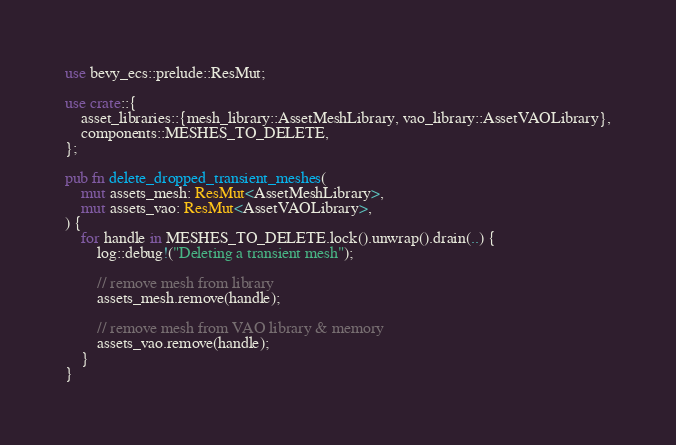<code> <loc_0><loc_0><loc_500><loc_500><_Rust_>use bevy_ecs::prelude::ResMut;

use crate::{
    asset_libraries::{mesh_library::AssetMeshLibrary, vao_library::AssetVAOLibrary},
    components::MESHES_TO_DELETE,
};

pub fn delete_dropped_transient_meshes(
    mut assets_mesh: ResMut<AssetMeshLibrary>,
    mut assets_vao: ResMut<AssetVAOLibrary>,
) {
    for handle in MESHES_TO_DELETE.lock().unwrap().drain(..) {
        log::debug!("Deleting a transient mesh");

        // remove mesh from library
        assets_mesh.remove(handle);

        // remove mesh from VAO library & memory
        assets_vao.remove(handle);
    }
}
</code> 